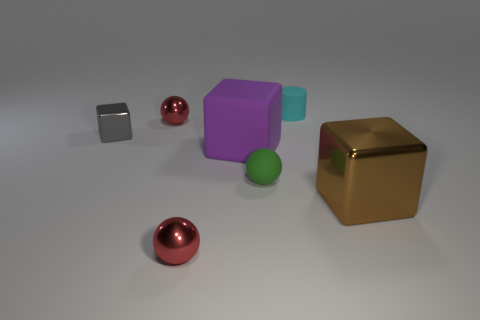Subtract all brown metal blocks. How many blocks are left? 2 Add 1 large brown matte cylinders. How many objects exist? 8 Subtract all green balls. How many balls are left? 2 Subtract all yellow blocks. How many red spheres are left? 2 Subtract all brown balls. Subtract all purple blocks. How many balls are left? 3 Subtract all large cyan cylinders. Subtract all gray metal blocks. How many objects are left? 6 Add 5 tiny metallic spheres. How many tiny metallic spheres are left? 7 Add 7 small blue rubber objects. How many small blue rubber objects exist? 7 Subtract 0 green cubes. How many objects are left? 7 Subtract all blocks. How many objects are left? 4 